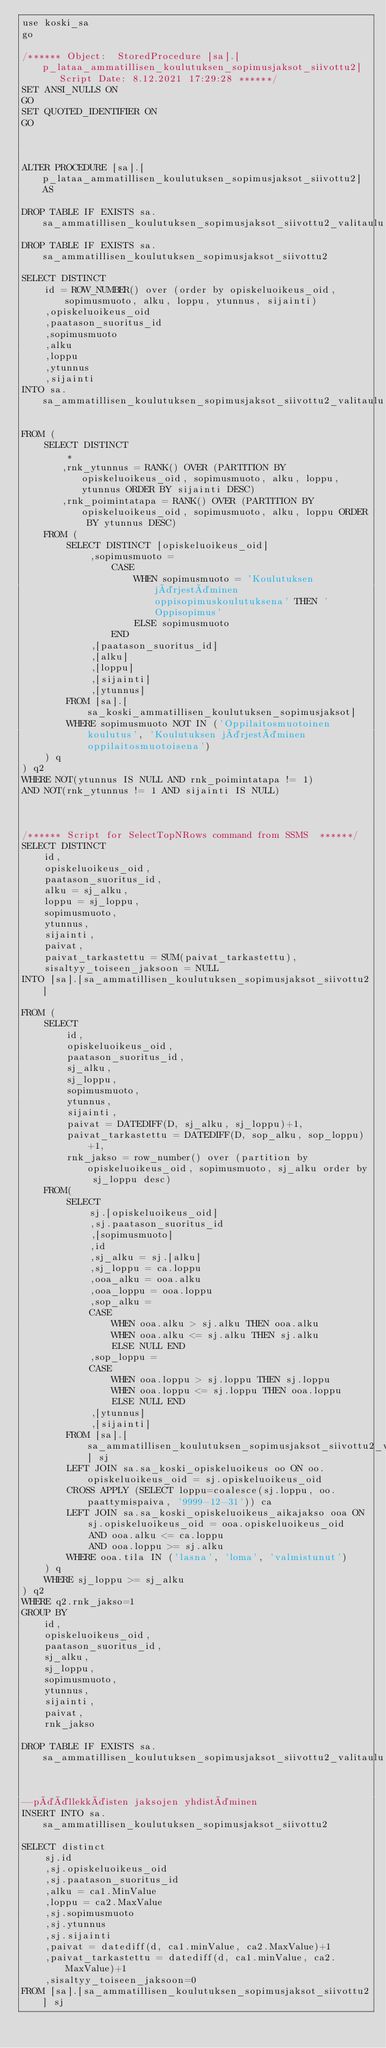<code> <loc_0><loc_0><loc_500><loc_500><_SQL_>use koski_sa
go

/****** Object:  StoredProcedure [sa].[p_lataa_ammatillisen_koulutuksen_sopimusjaksot_siivottu2]    Script Date: 8.12.2021 17:29:28 ******/
SET ANSI_NULLS ON
GO
SET QUOTED_IDENTIFIER ON
GO



ALTER PROCEDURE [sa].[p_lataa_ammatillisen_koulutuksen_sopimusjaksot_siivottu2] AS

DROP TABLE IF EXISTS sa.sa_ammatillisen_koulutuksen_sopimusjaksot_siivottu2_valitaulu
DROP TABLE IF EXISTS sa.sa_ammatillisen_koulutuksen_sopimusjaksot_siivottu2

SELECT DISTINCT 
	id = ROW_NUMBER() over (order by opiskeluoikeus_oid, sopimusmuoto, alku, loppu, ytunnus, sijainti)
	,opiskeluoikeus_oid
	,paatason_suoritus_id
	,sopimusmuoto
	,alku
	,loppu
	,ytunnus
	,sijainti
INTO sa.sa_ammatillisen_koulutuksen_sopimusjaksot_siivottu2_valitaulu

FROM (
	SELECT DISTINCT 
		* 
	   ,rnk_ytunnus = RANK() OVER (PARTITION BY opiskeluoikeus_oid, sopimusmuoto, alku, loppu, ytunnus ORDER BY sijainti DESC)
	   ,rnk_poimintatapa = RANK() OVER (PARTITION BY opiskeluoikeus_oid, sopimusmuoto, alku, loppu ORDER BY ytunnus DESC)
	FROM (
		SELECT DISTINCT [opiskeluoikeus_oid]
			,sopimusmuoto =
				CASE 
					WHEN sopimusmuoto = 'Koulutuksen järjestäminen oppisopimuskoulutuksena' THEN 'Oppisopimus'
					ELSE sopimusmuoto
				END
			,[paatason_suoritus_id]
			,[alku]
			,[loppu]
			,[sijainti]
			,[ytunnus]
		FROM [sa].[sa_koski_ammatillisen_koulutuksen_sopimusjaksot]
		WHERE sopimusmuoto NOT IN ('Oppilaitosmuotoinen koulutus', 'Koulutuksen järjestäminen oppilaitosmuotoisena')
	) q
) q2
WHERE NOT(ytunnus IS NULL AND rnk_poimintatapa != 1)
AND NOT(rnk_ytunnus != 1 AND sijainti IS NULL)



/****** Script for SelectTopNRows command from SSMS  ******/
SELECT DISTINCT
	id,
	opiskeluoikeus_oid,
	paatason_suoritus_id,
	alku = sj_alku,
	loppu = sj_loppu,
	sopimusmuoto,
	ytunnus,
	sijainti,
	paivat,
	paivat_tarkastettu = SUM(paivat_tarkastettu),
	sisaltyy_toiseen_jaksoon = NULL
INTO [sa].[sa_ammatillisen_koulutuksen_sopimusjaksot_siivottu2]

FROM (
	SELECT
		id,
		opiskeluoikeus_oid,
		paatason_suoritus_id,
		sj_alku,
		sj_loppu,
		sopimusmuoto,
		ytunnus,
		sijainti,
		paivat = DATEDIFF(D, sj_alku, sj_loppu)+1,
		paivat_tarkastettu = DATEDIFF(D, sop_alku, sop_loppu)+1,
		rnk_jakso = row_number() over (partition by opiskeluoikeus_oid, sopimusmuoto, sj_alku order by sj_loppu desc)
	FROM(
		SELECT 
			sj.[opiskeluoikeus_oid]
			,sj.paatason_suoritus_id
			,[sopimusmuoto]
			,id
			,sj_alku = sj.[alku] 
			,sj_loppu = ca.loppu
			,ooa_alku = ooa.alku
			,ooa_loppu = ooa.loppu
			,sop_alku =
			CASE 
				WHEN ooa.alku > sj.alku THEN ooa.alku
				WHEN ooa.alku <= sj.alku THEN sj.alku
				ELSE NULL END
			,sop_loppu =
			CASE
				WHEN ooa.loppu > sj.loppu THEN sj.loppu
				WHEN ooa.loppu <= sj.loppu THEN ooa.loppu
				ELSE NULL END
			,[ytunnus]
			,[sijainti]
		FROM [sa].[sa_ammatillisen_koulutuksen_sopimusjaksot_siivottu2_valitaulu] sj
		LEFT JOIN sa.sa_koski_opiskeluoikeus oo ON oo.opiskeluoikeus_oid = sj.opiskeluoikeus_oid
		CROSS APPLY (SELECT loppu=coalesce(sj.loppu, oo.paattymispaiva, '9999-12-31')) ca
		LEFT JOIN sa.sa_koski_opiskeluoikeus_aikajakso ooa ON sj.opiskeluoikeus_oid = ooa.opiskeluoikeus_oid
			AND ooa.alku <= ca.loppu
			AND ooa.loppu >= sj.alku
		WHERE ooa.tila IN ('lasna', 'loma', 'valmistunut')
	) q
	WHERE sj_loppu >= sj_alku
) q2
WHERE q2.rnk_jakso=1
GROUP BY
	id,
	opiskeluoikeus_oid,
	paatason_suoritus_id,
	sj_alku,
	sj_loppu,
	sopimusmuoto,
	ytunnus,
	sijainti,
	paivat,
	rnk_jakso

DROP TABLE IF EXISTS sa.sa_ammatillisen_koulutuksen_sopimusjaksot_siivottu2_valitaulu


--päällekkäisten jaksojen yhdistäminen
INSERT INTO sa.sa_ammatillisen_koulutuksen_sopimusjaksot_siivottu2

SELECT distinct
	sj.id
	,sj.opiskeluoikeus_oid
	,sj.paatason_suoritus_id
	,alku = ca1.MinValue
	,loppu = ca2.MaxValue
	,sj.sopimusmuoto
	,sj.ytunnus
	,sj.sijainti
	,paivat = datediff(d, ca1.minValue, ca2.MaxValue)+1
	,paivat_tarkastettu = datediff(d, ca1.minValue, ca2.MaxValue)+1
	,sisaltyy_toiseen_jaksoon=0
FROM [sa].[sa_ammatillisen_koulutuksen_sopimusjaksot_siivottu2] sj</code> 